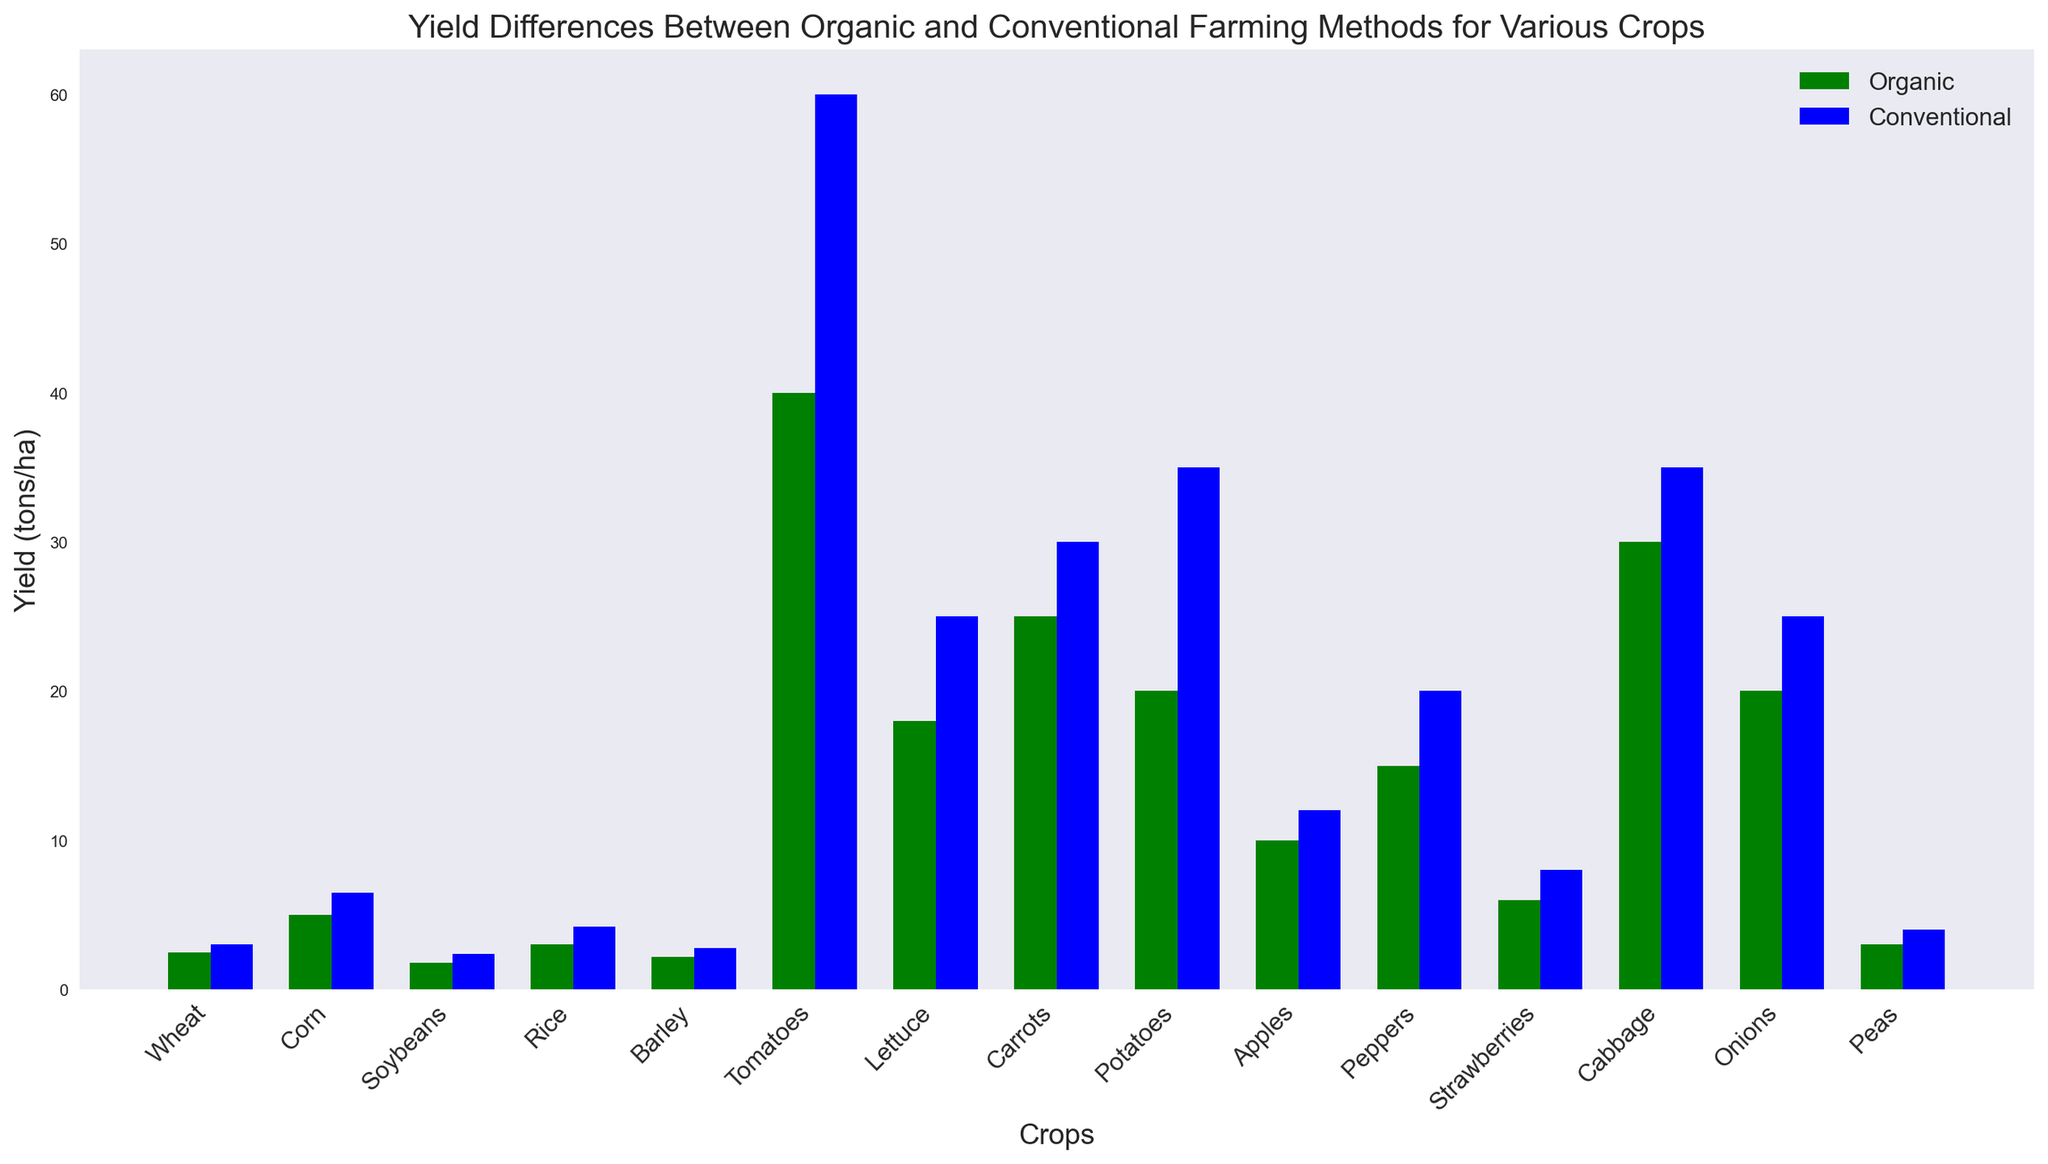What's the general trend shown in the figure for the yield differences between organic and conventional farming? Observe that for most crops, the conventional farming yield bars (blue) are higher than the organic farming yield bars (green). This indicates that conventional methods generally yield higher quantities of crops compared to organic methods.
Answer: Conventional farming generally yields higher Which crop has the largest absolute yield difference between organic and conventional farming? To find the crop with the largest absolute yield difference, compare the differences between the heights of the organic and conventional bars for each crop. The largest difference is between organic and conventional yields for tomatoes (60 - 40 = 20 tons/ha).
Answer: Tomatoes What is the smallest yield difference (in tons/ha) for any crop between organic and conventional farming? Compare the yield differences for all the crops to find the smallest difference, which is the difference between organic and conventional yields for apples (12 - 10 = 2 tons/ha).
Answer: Apples Which crop has the highest yield using organic methods? Identify the tallest green bar in the chart, representing the highest yield using organic methods. The crop with the highest organic yield is tomatoes (40 tons/ha).
Answer: Tomatoes Which crop has a higher organic yield than conventional yield? Compare the heights of green and blue bars for each crop. None of the organic yields exceed their corresponding conventional yields; hence, no crop has a higher organic yield than conventional yield in the figure.
Answer: None What is the average yield (in tons/ha) for organic farming across all crops? Add all the organic yield values: (2.5 + 5.0 + 1.8 + 3.0 + 2.2 + 40.0 + 18.0 + 25.0 + 20.0 + 10.0 + 15.0 + 6.0 + 30.0 + 20.0 + 3.0) = 201.5, then divide by the number of crops (15): 201.5/15 ≈ 13.43 tons/ha.
Answer: 13.43 tons/ha Between peppers and strawberries, which crop has a greater yield difference between organic and conventional farming methods? Calculate the yield differences for both crops: Peppers (20 - 15 = 5 tons/ha) and Strawberries (8 - 6 = 2 tons/ha). Peppers have a greater yield difference.
Answer: Peppers What is the total yield (in tons/ha) for conventional farming of wheat, corn, and rice combined? Add the conventional yield values for wheat, corn, and rice: (3.0 + 6.5 + 4.2) = 13.7 tons/ha.
Answer: 13.7 tons/ha Which farming method shows the higher yield for carrots and by how much? Compare the orange (organic) and blue (conventional) bars for carrots and find the difference: Conventional farming has a higher yield (30 - 25 = 5 tons/ha).
Answer: Conventional by 5 tons/ha What is the total organic yield (in tons/ha) for the crops that have a conventional yield higher than 35 tons/ha? Identify crops with conventional yields higher than 35 tons/ha (Tomatoes, Carrots, Potatoes, Cabbage) and sum their organic yields: 40 + 25 + 20 + 30 = 115 tons/ha.
Answer: 115 tons/ha 